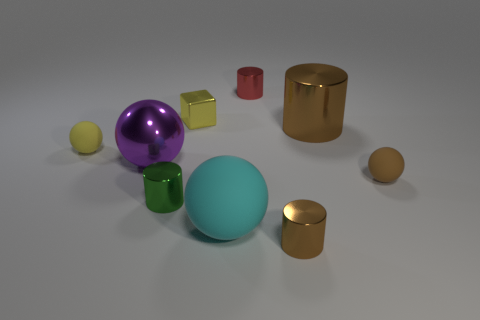Which object seems out of place and why? All objects seem to be placed deliberately as part of a collection for either a display or an arrangement for a computational task. However, if we were to identify one that stands out, it might be the single red cube due to its color contrast with the other objects which are either metallic or softer in hue. Visually, it commands attention because it contrasts sharply against the less saturated colors in the image. 